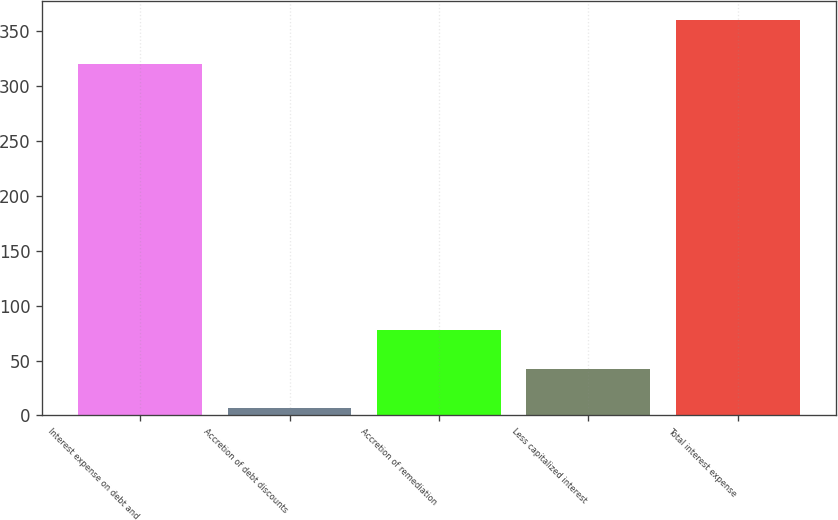Convert chart to OTSL. <chart><loc_0><loc_0><loc_500><loc_500><bar_chart><fcel>Interest expense on debt and<fcel>Accretion of debt discounts<fcel>Accretion of remediation<fcel>Less capitalized interest<fcel>Total interest expense<nl><fcel>319.8<fcel>6.9<fcel>77.52<fcel>42.21<fcel>360<nl></chart> 